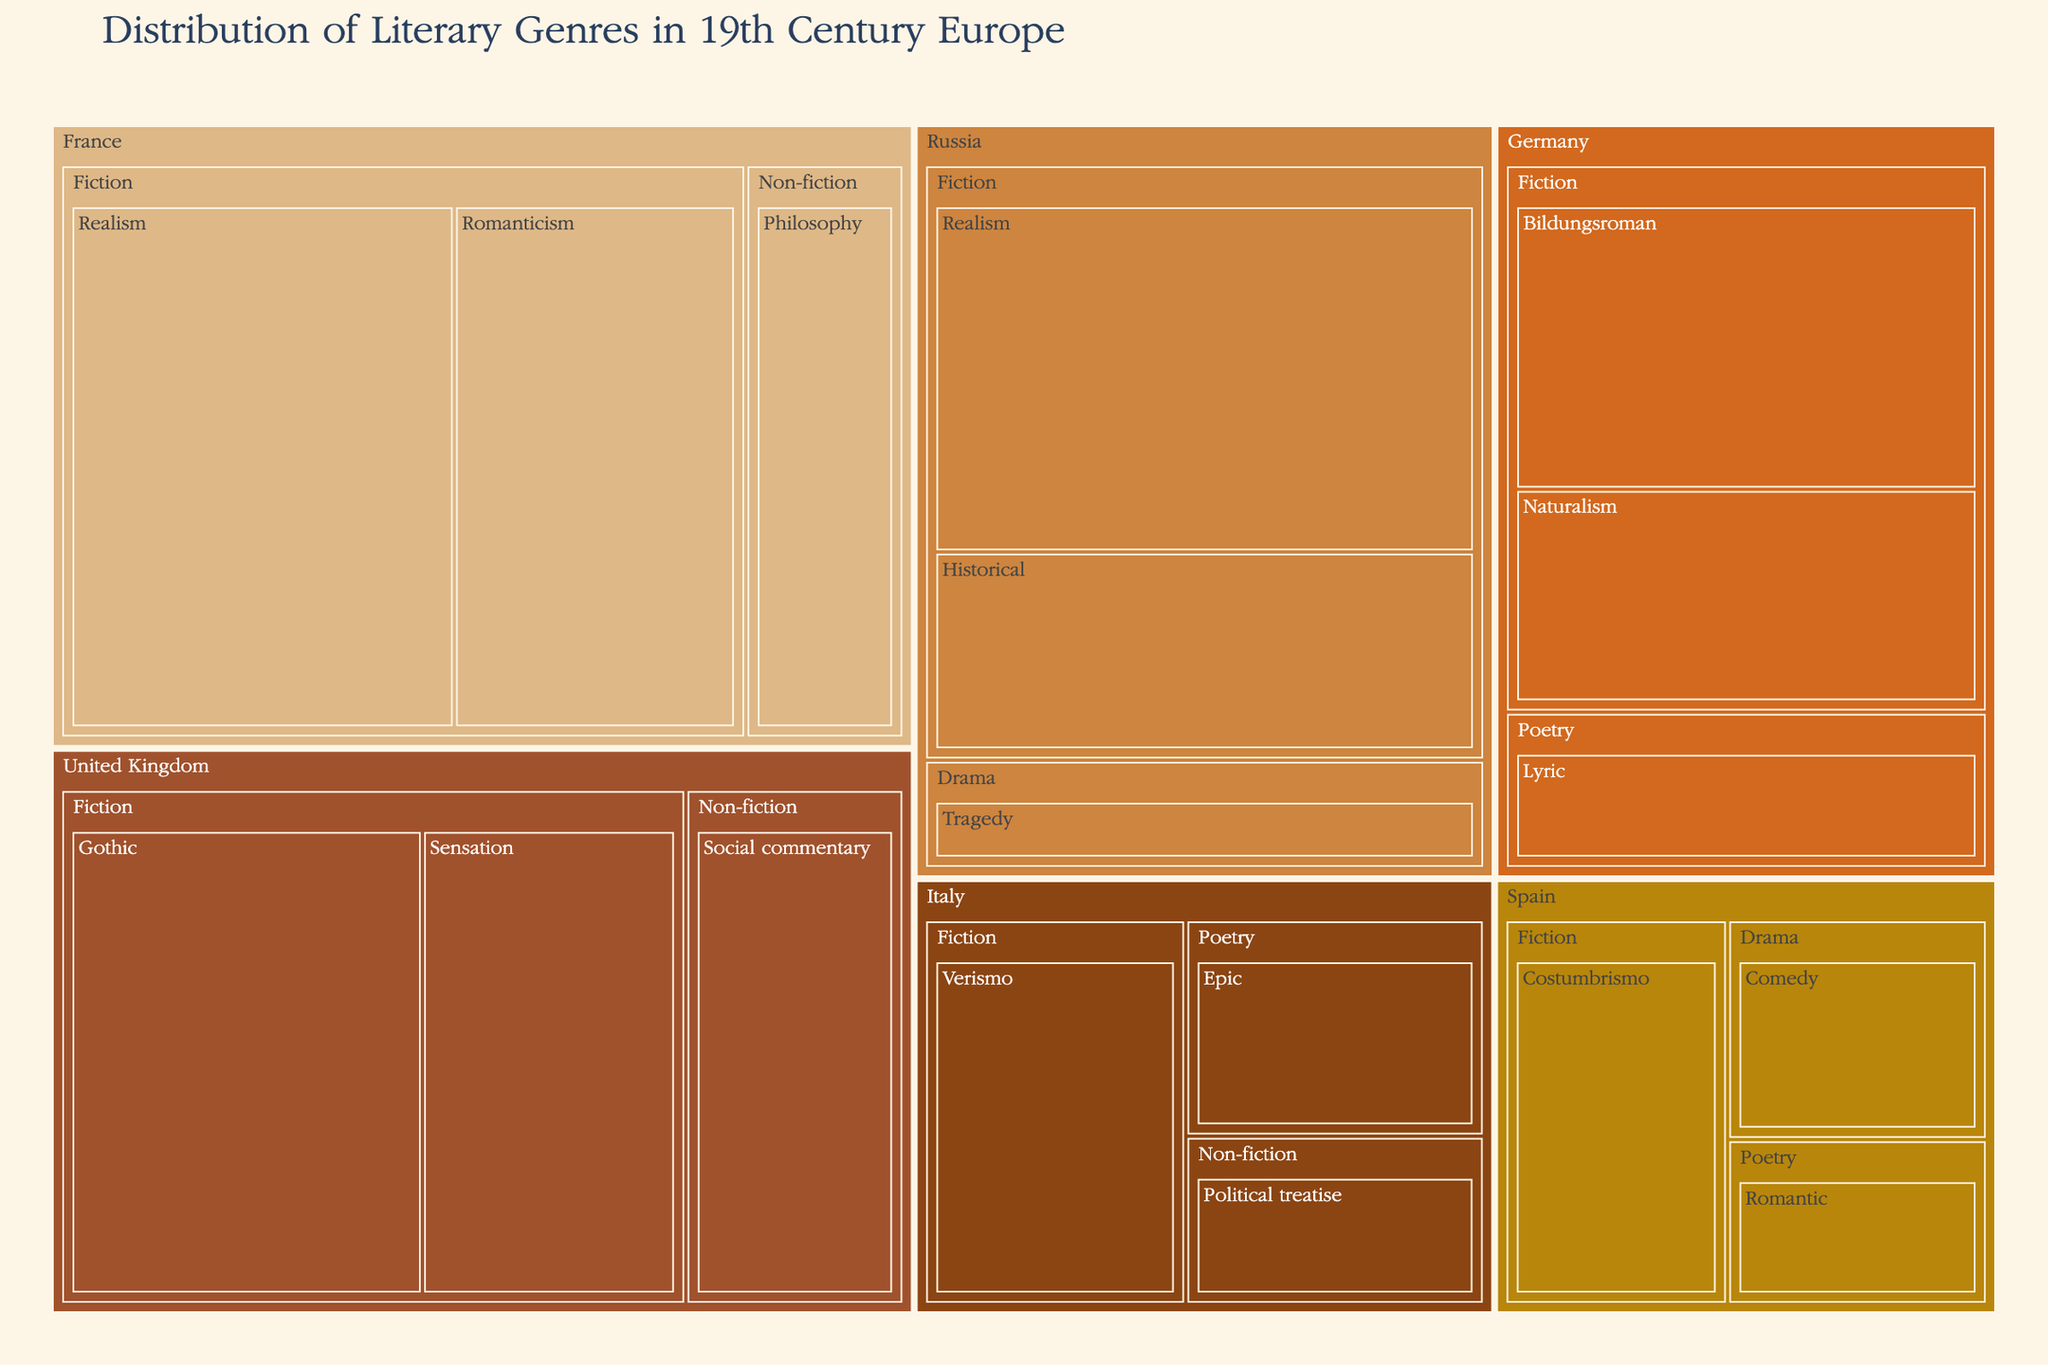What is the title of the treemap? The title is usually prominently displayed at the top of the treemap and summarizes the content of the figure.
Answer: Distribution of Literary Genres in 19th Century Europe Which country has the highest value for Fiction genres? The largest section labeled Fiction within the treemap for each country will indicate the highest value.
Answer: France How many sub-genres are there under the Fiction genre in the United Kingdom? Each distinct smaller section labeled under Fiction for the United Kingdom within the treemap is a sub-genre.
Answer: 2 Which sub-genre has the highest value in Germany? Locate Germany on the treemap, then within it, identify the sub-genre with the largest area or the highest value label.
Answer: Bildungsroman What is the combined value of Non-fiction genres in the United Kingdom and France? Sum the values of Non-fiction sub-genres under the United Kingdom and France.
Answer: 27 (15 from UK + 12 from France) Which sub-genre in Russia has a value closest to 20? Look for sub-genres within the Russian section of the treemap that have value labels close to 20.
Answer: Historical at 16 Which country has more Drama sub-genres, Russia or Spain? Compare the number of sections labeled Drama within Russia and Spain on the treemap.
Answer: Spain What is the total value of Poetry genres across all countries? Sum the values of all sub-genres under the Poetry genre from each country.
Answer: 25 (10 from Germany + 9 from Italy + 6 from Spain) Among the listed countries, which has the broadest variety of literary sub-genres? Determine the country with the greatest number of distinct sections (sub-genres) within its area of the treemap.
Answer: United Kingdom What is the least prevalent sub-genre in the treemap, and which country does it belong to? Identify the smallest section or lowest value across the entire treemap and note the associated country and sub-genre.
Answer: Political treatise in Italy at 7 